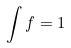Convert formula to latex. <formula><loc_0><loc_0><loc_500><loc_500>\int f = 1</formula> 